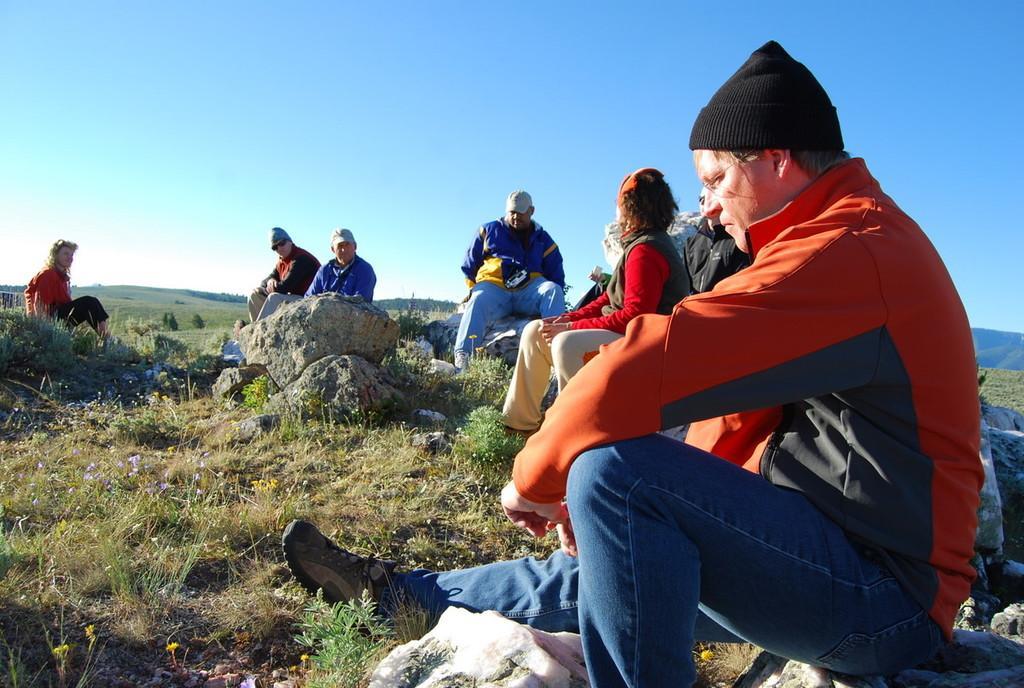Can you describe this image briefly? In the image there are people sitting on the rocks. And there are few people with caps on their heads. On the ground there is grass and also there are flowers. In the background there are hills. At the top of the image there is sky. 